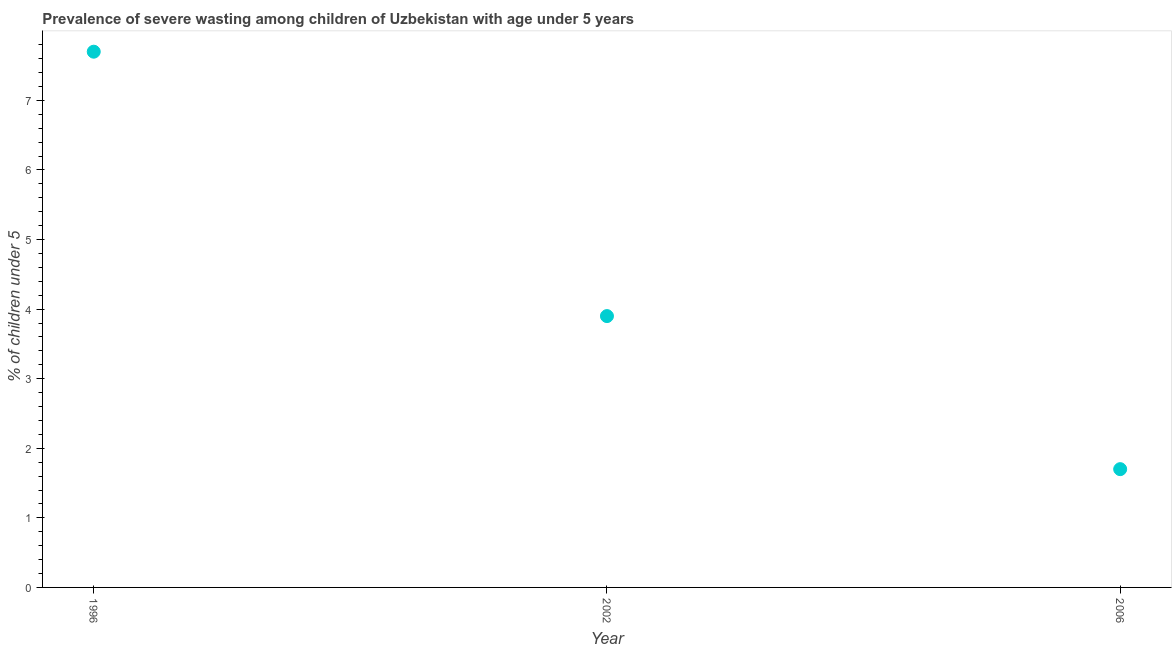What is the prevalence of severe wasting in 2002?
Provide a short and direct response. 3.9. Across all years, what is the maximum prevalence of severe wasting?
Ensure brevity in your answer.  7.7. Across all years, what is the minimum prevalence of severe wasting?
Your response must be concise. 1.7. What is the sum of the prevalence of severe wasting?
Make the answer very short. 13.3. What is the difference between the prevalence of severe wasting in 2002 and 2006?
Keep it short and to the point. 2.2. What is the average prevalence of severe wasting per year?
Offer a terse response. 4.43. What is the median prevalence of severe wasting?
Provide a short and direct response. 3.9. Do a majority of the years between 1996 and 2002 (inclusive) have prevalence of severe wasting greater than 5.2 %?
Your response must be concise. No. What is the ratio of the prevalence of severe wasting in 1996 to that in 2006?
Give a very brief answer. 4.53. Is the difference between the prevalence of severe wasting in 1996 and 2002 greater than the difference between any two years?
Provide a short and direct response. No. What is the difference between the highest and the second highest prevalence of severe wasting?
Keep it short and to the point. 3.8. Is the sum of the prevalence of severe wasting in 2002 and 2006 greater than the maximum prevalence of severe wasting across all years?
Your answer should be very brief. No. What is the difference between the highest and the lowest prevalence of severe wasting?
Your answer should be very brief. 6. In how many years, is the prevalence of severe wasting greater than the average prevalence of severe wasting taken over all years?
Ensure brevity in your answer.  1. Does the prevalence of severe wasting monotonically increase over the years?
Give a very brief answer. No. How many dotlines are there?
Provide a short and direct response. 1. How many years are there in the graph?
Ensure brevity in your answer.  3. Does the graph contain any zero values?
Keep it short and to the point. No. Does the graph contain grids?
Provide a short and direct response. No. What is the title of the graph?
Ensure brevity in your answer.  Prevalence of severe wasting among children of Uzbekistan with age under 5 years. What is the label or title of the Y-axis?
Offer a terse response.  % of children under 5. What is the  % of children under 5 in 1996?
Make the answer very short. 7.7. What is the  % of children under 5 in 2002?
Offer a terse response. 3.9. What is the  % of children under 5 in 2006?
Provide a short and direct response. 1.7. What is the difference between the  % of children under 5 in 1996 and 2006?
Offer a terse response. 6. What is the ratio of the  % of children under 5 in 1996 to that in 2002?
Make the answer very short. 1.97. What is the ratio of the  % of children under 5 in 1996 to that in 2006?
Give a very brief answer. 4.53. What is the ratio of the  % of children under 5 in 2002 to that in 2006?
Your answer should be very brief. 2.29. 